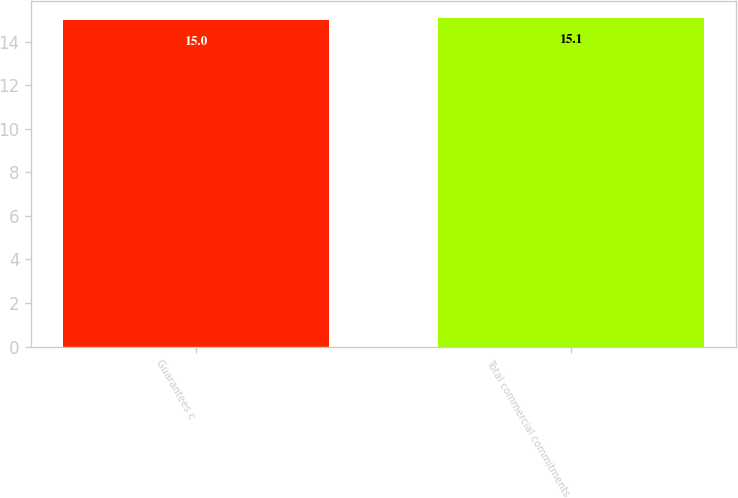<chart> <loc_0><loc_0><loc_500><loc_500><bar_chart><fcel>Guarantees c<fcel>Total commercial commitments<nl><fcel>15<fcel>15.1<nl></chart> 